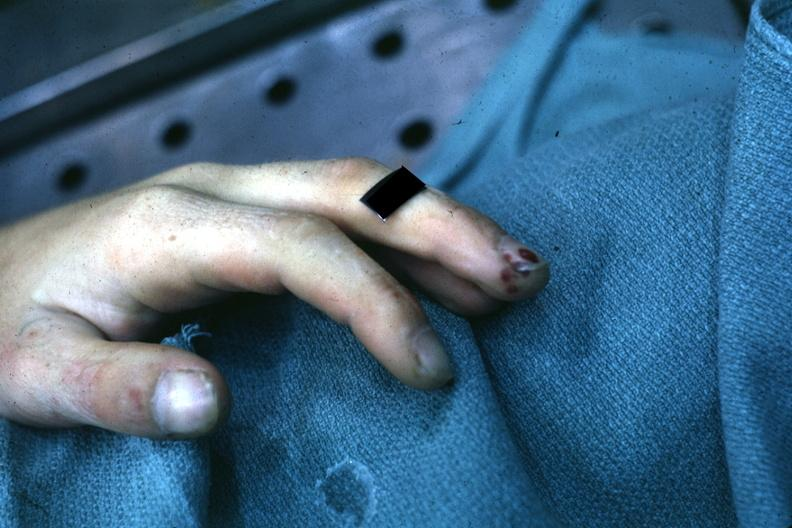what are present?
Answer the question using a single word or phrase. Extremities 